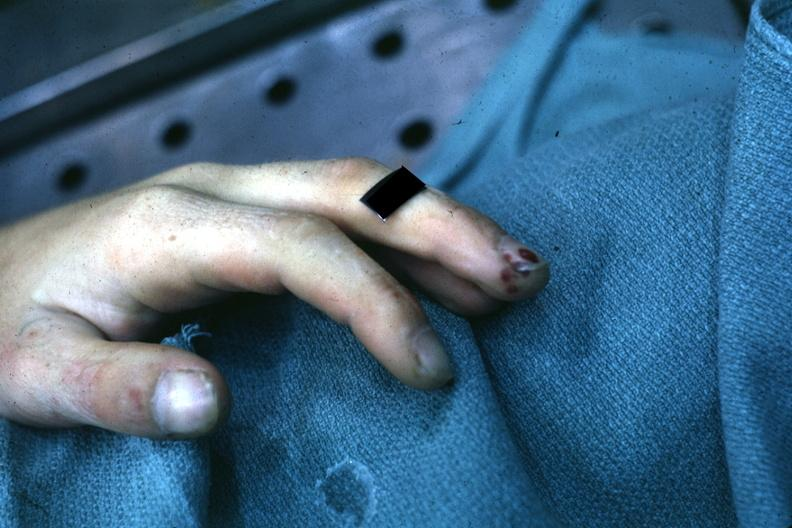what are present?
Answer the question using a single word or phrase. Extremities 